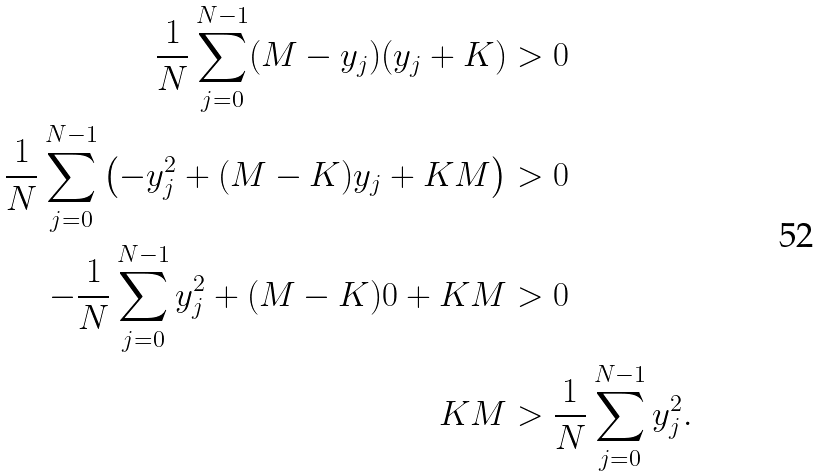<formula> <loc_0><loc_0><loc_500><loc_500>\frac { 1 } { N } \sum _ { j = 0 } ^ { N - 1 } ( M - y _ { j } ) ( y _ { j } + K ) & > 0 \\ \frac { 1 } { N } \sum _ { j = 0 } ^ { N - 1 } \left ( - y _ { j } ^ { 2 } + ( M - K ) y _ { j } + K M \right ) & > 0 \\ - \frac { 1 } { N } \sum _ { j = 0 } ^ { N - 1 } y _ { j } ^ { 2 } + ( M - K ) 0 + K M & > 0 \\ K M & > \frac { 1 } { N } \sum _ { j = 0 } ^ { N - 1 } y _ { j } ^ { 2 } .</formula> 